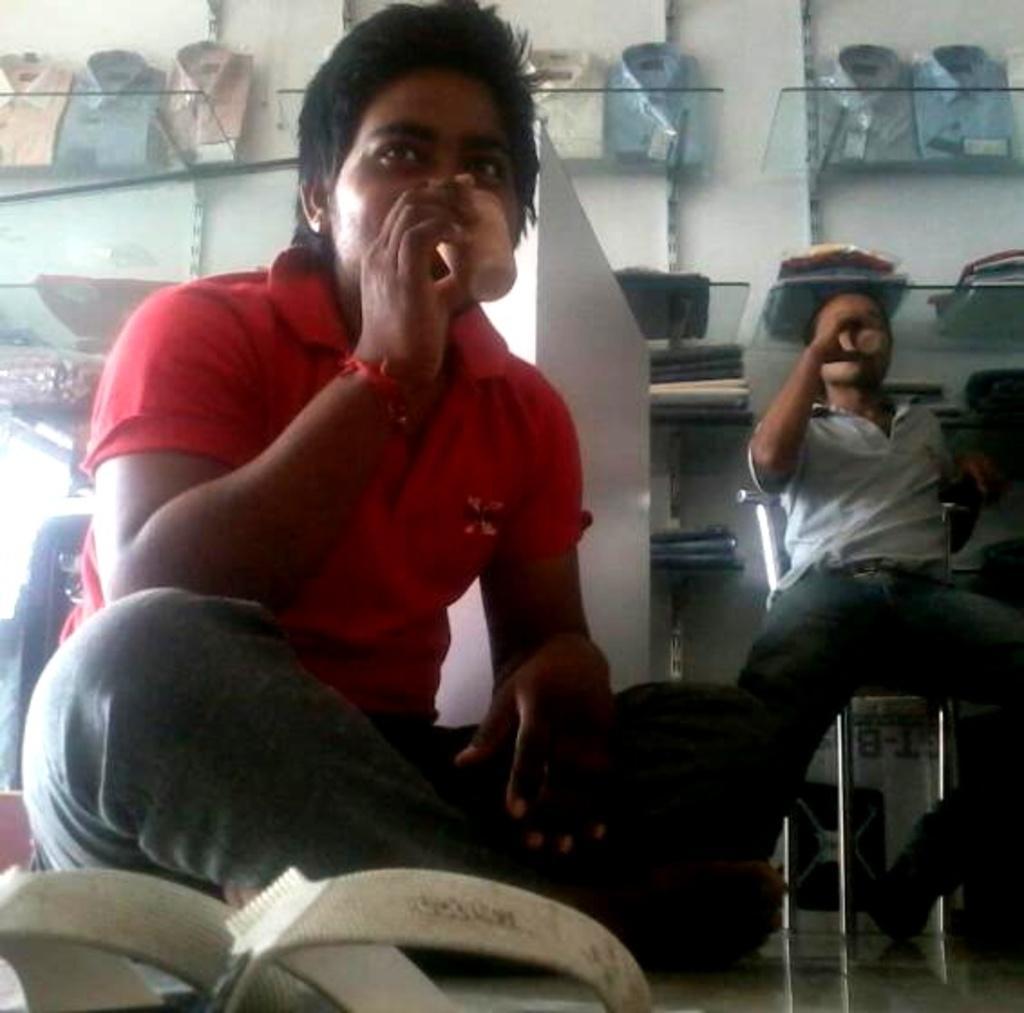In one or two sentences, can you explain what this image depicts? In this picture I can see the footwear in front and I see 2 men who are sitting and both of them are holding glasses and in the background I see the glass rack on which there are shirts. 